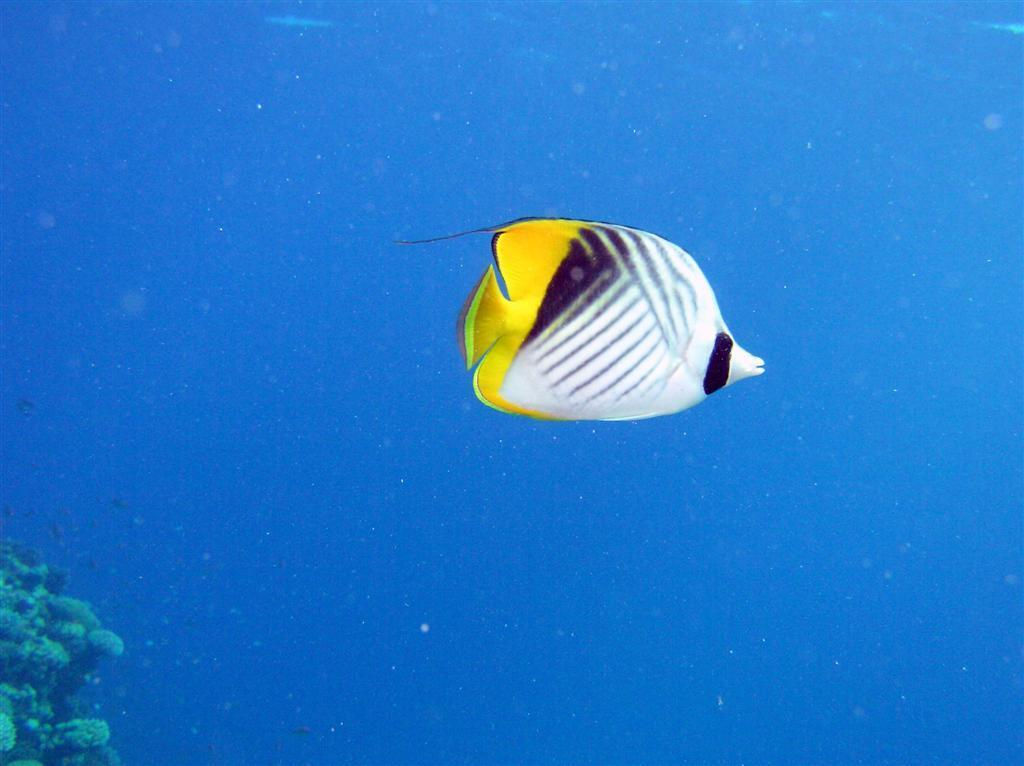What type of animal can be seen in the water in the image? There is a fish in the water in the image. What other living organism is present in the image? There is a plant in the image. What type of thunder can be heard in the image? There is no thunder present in the image, as it is a still image and cannot produce sound. 